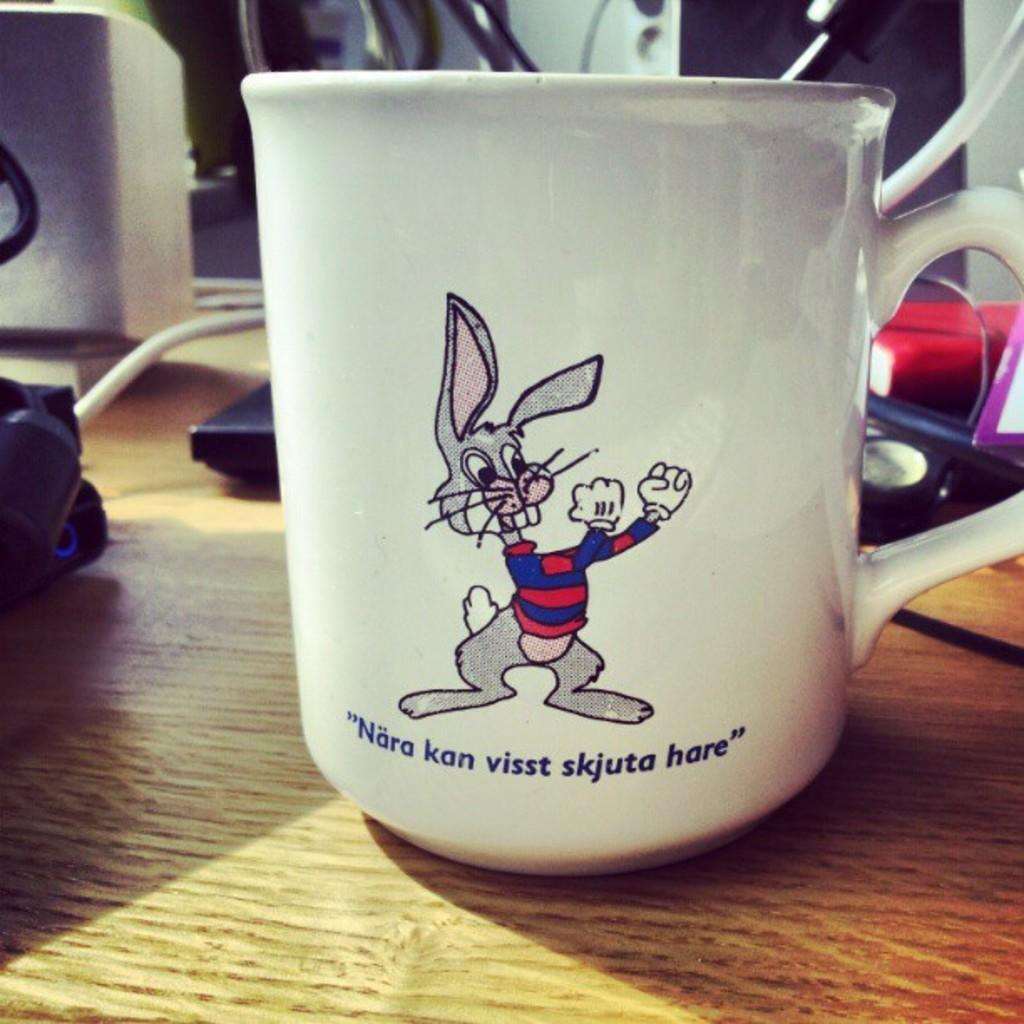<image>
Offer a succinct explanation of the picture presented. A white coffee mug with a bunny and words in a language that is not English on it. 